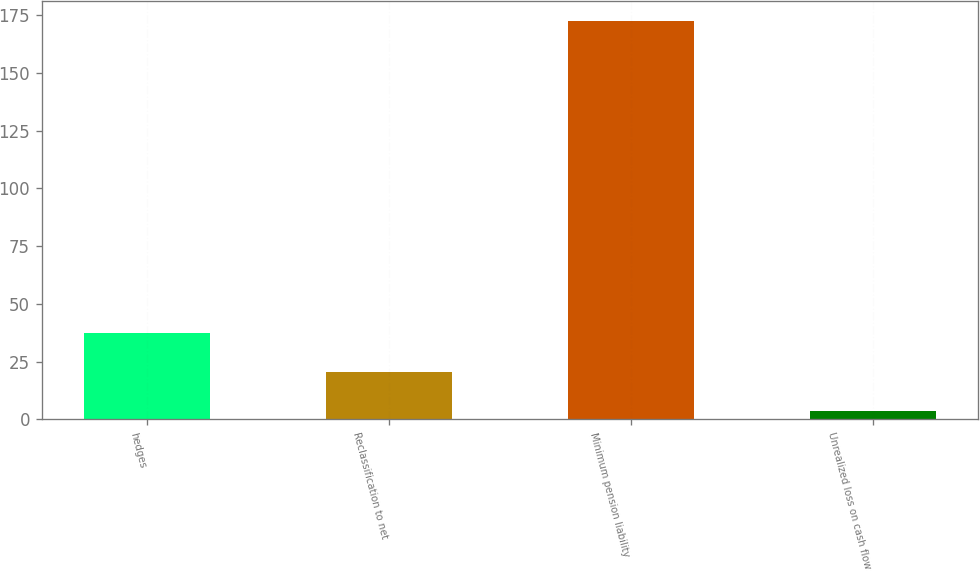Convert chart. <chart><loc_0><loc_0><loc_500><loc_500><bar_chart><fcel>hedges<fcel>Reclassification to net<fcel>Minimum pension liability<fcel>Unrealized loss on cash flow<nl><fcel>37.42<fcel>20.56<fcel>172.3<fcel>3.7<nl></chart> 